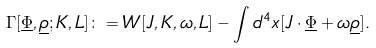Convert formula to latex. <formula><loc_0><loc_0><loc_500><loc_500>\Gamma [ \underline { \Phi } , \underline { \rho } ; K , L ] \colon = W [ J , K , \omega , L ] - \int d ^ { 4 } x [ J \cdot \underline { \Phi } + \omega \underline { \rho } ] .</formula> 